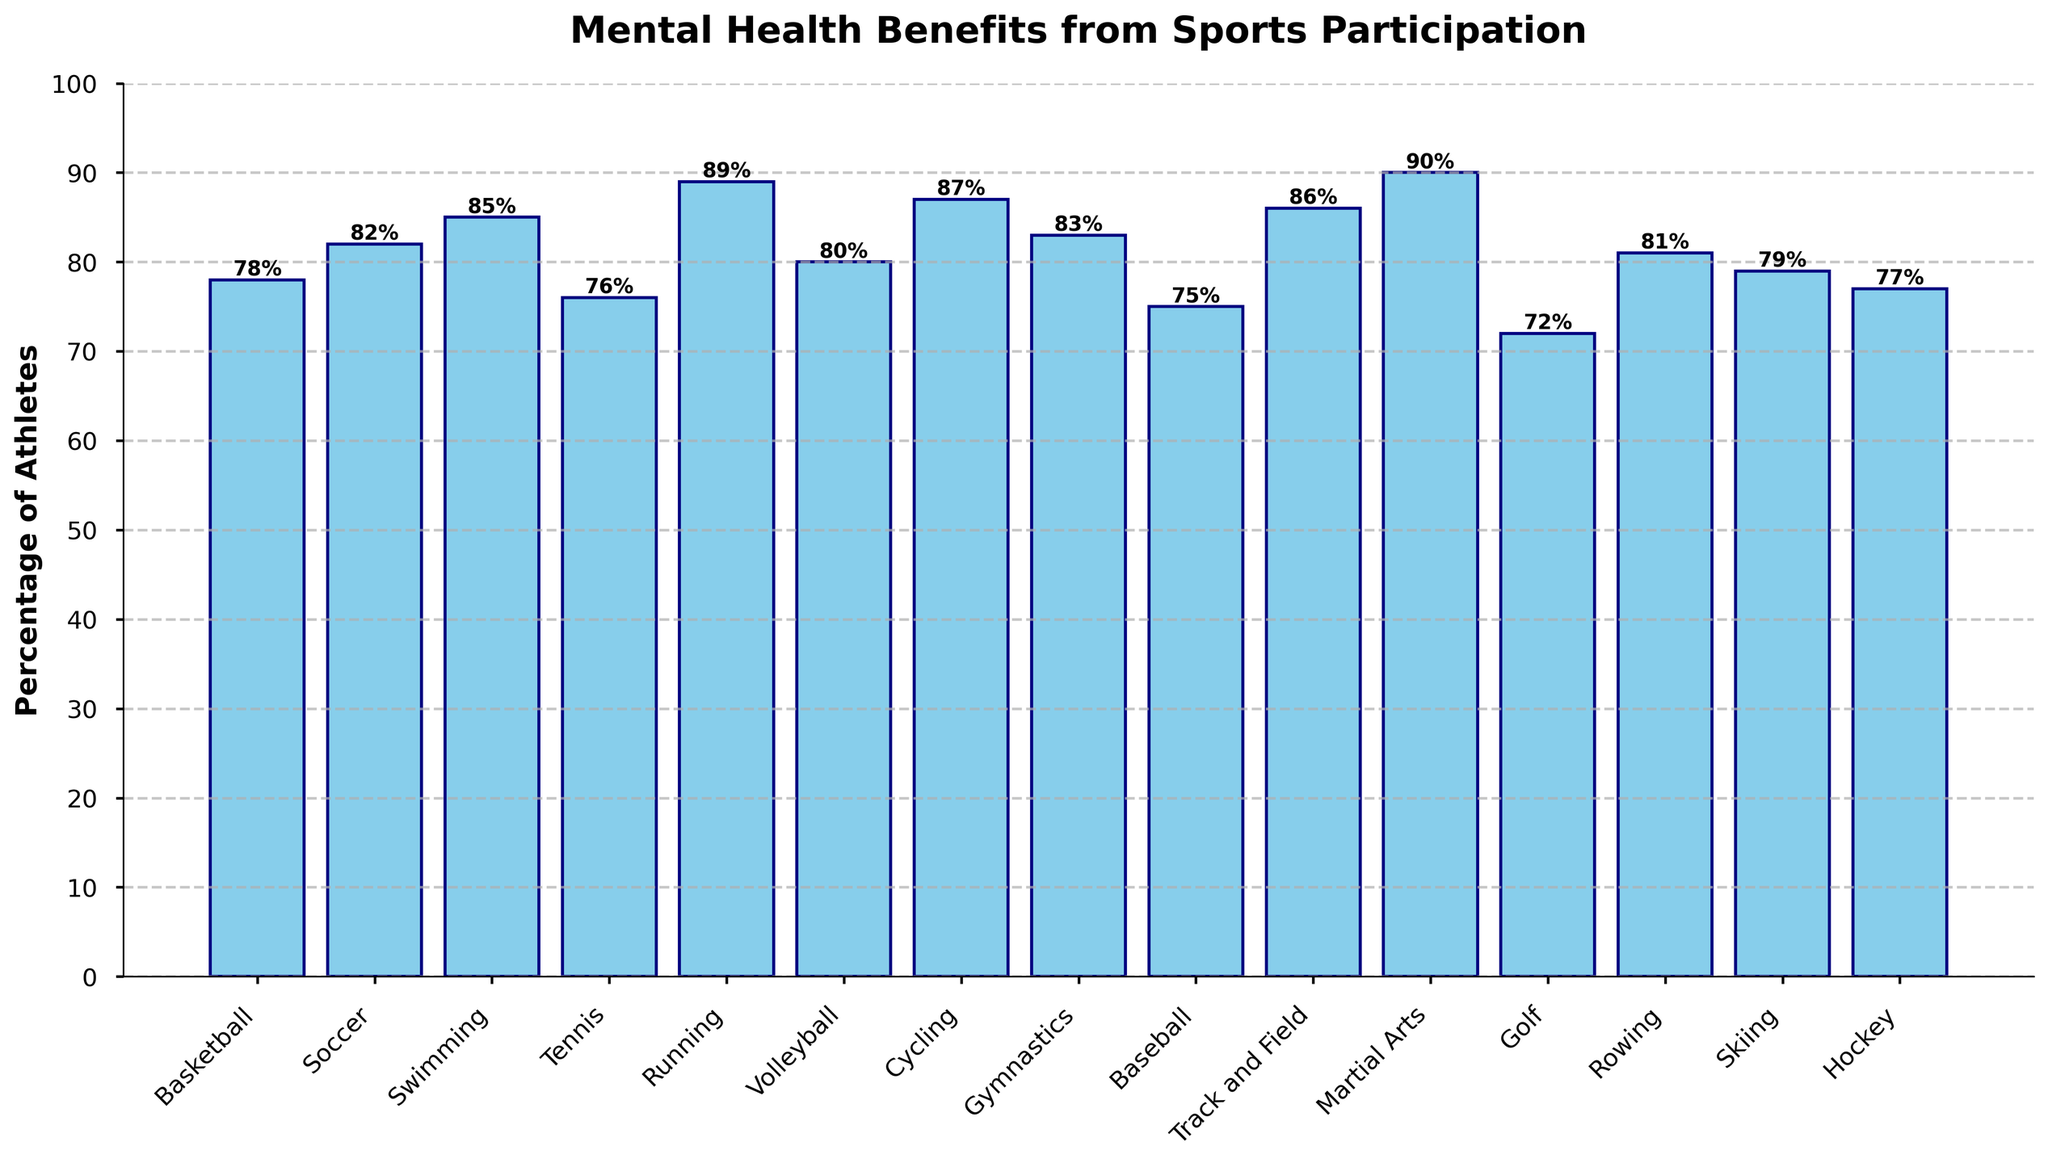What's the percentage of athletes in Running who report mental health benefits from sports participation? The bar corresponding to Running shows a height with a textual annotation indicating 89%. This denotes the percentage of athletes in Running who report mental health benefits from participating in sports.
Answer: 89% Which sport has the highest percentage of athletes reporting mental health benefits from sports participation? Observing the heights of all the bars, the bar for Martial Arts is the tallest, with a value of 90%, indicating it has the highest percentage of athletes reporting mental health benefits.
Answer: Martial Arts What is the average percentage of athletes reporting mental health benefits across all sports? To find the average, sum up the percentages for all sports (78 + 82 + 85 + 76 + 89 + 80 + 87 + 83 + 75 + 86 + 90 + 72 + 81 + 79 + 77 = 1230) and divide by the number of sports (15). The average is 1230 / 15 = 82%.
Answer: 82% How many sports have a percentage of athletes reporting mental health benefits higher than 80%? By inspecting the figure, count the bars with heights above the 80% mark. The sports above 80% are Soccer, Swimming, Running, Cycling, Gymnastics, Track and Field, and Martial Arts. This gives a total of 7 sports.
Answer: 7 Which sport has the lowest percentage of athletes reporting mental health benefits from sports participation? From the visual inspection, the shortest bar belongs to Golf, with a value of 72%, indicating it has the lowest percentage of athletes reporting mental health benefits.
Answer: Golf What is the difference in the percentage of athletes reporting mental health benefits between Soccer and Basketball? The figure shows Soccer at 82% and Basketball at 78%. Subtracting 78 from 82 gives the difference: 82% - 78% = 4%.
Answer: 4% If you sum the percentages of Basketball, Tennis, Baseball, and Hockey, what is the total? The percentages for Basketball, Tennis, Baseball, and Hockey are 78%, 76%, 75%, and 77% respectively. Summing these values gives 78 + 76 + 75 + 77 = 306.
Answer: 306 Which has a higher percentage of athletes reporting mental health benefits, Swimming or Tennis? Comparing the heights of the bars, Swimming stands at 85% and Tennis at 76%. Therefore, Swimming has a higher percentage.
Answer: Swimming Are there any sports where the percentage of athletes reporting mental health benefits is exactly 80%? By examining the bars, Volleyball has a percentage of 80%, so it matches the criteria.
Answer: Volleyball What is the median percentage for the sports' athletes reporting mental health benefits? To find the median, order the percentages: 72, 75, 76, 77, 78, 79, 80, 81, 82, 83, 85, 86, 87, 89, 90. The middle value, or the 8th value, is 81%.
Answer: 81% 